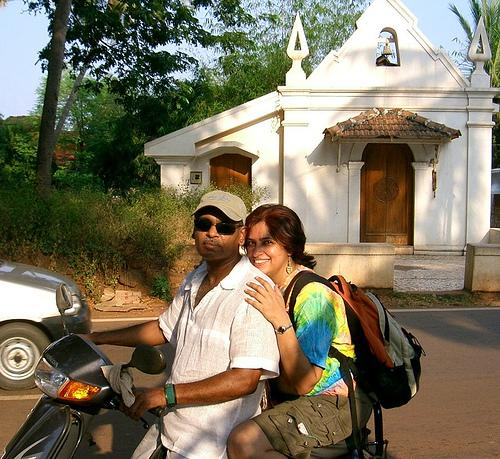What season is most likely? Please explain your reasoning. summer. The season is summer. 